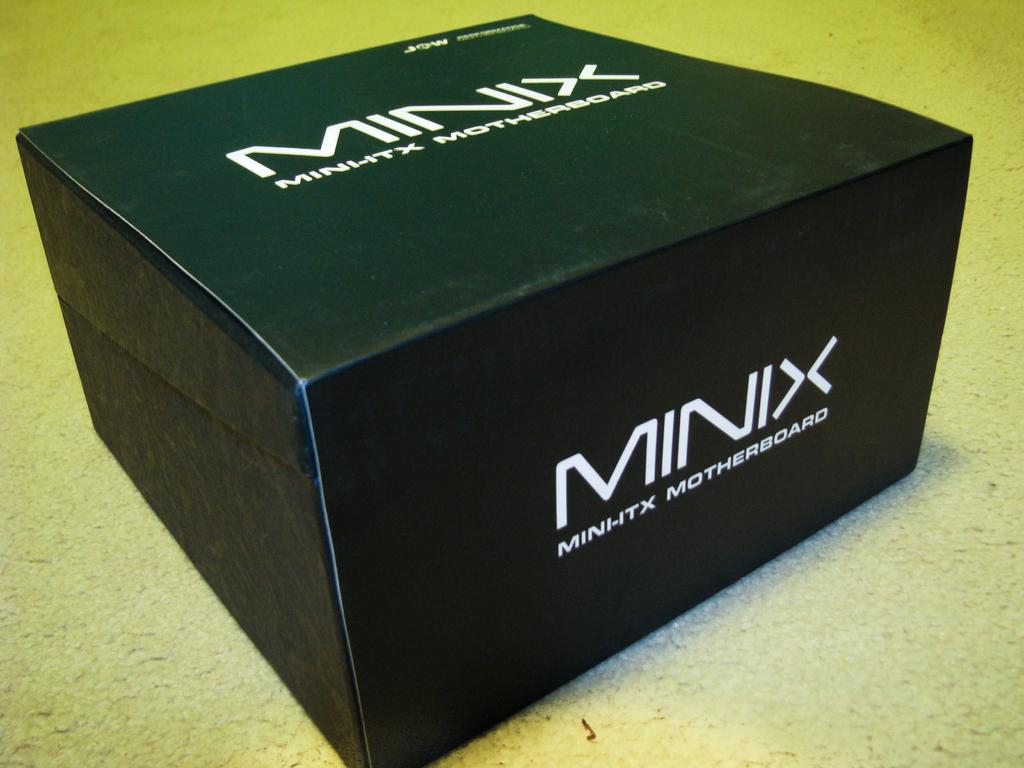Provide a one-sentence caption for the provided image. A blackbox contains a Minix Minhtx Motherboard inside. 